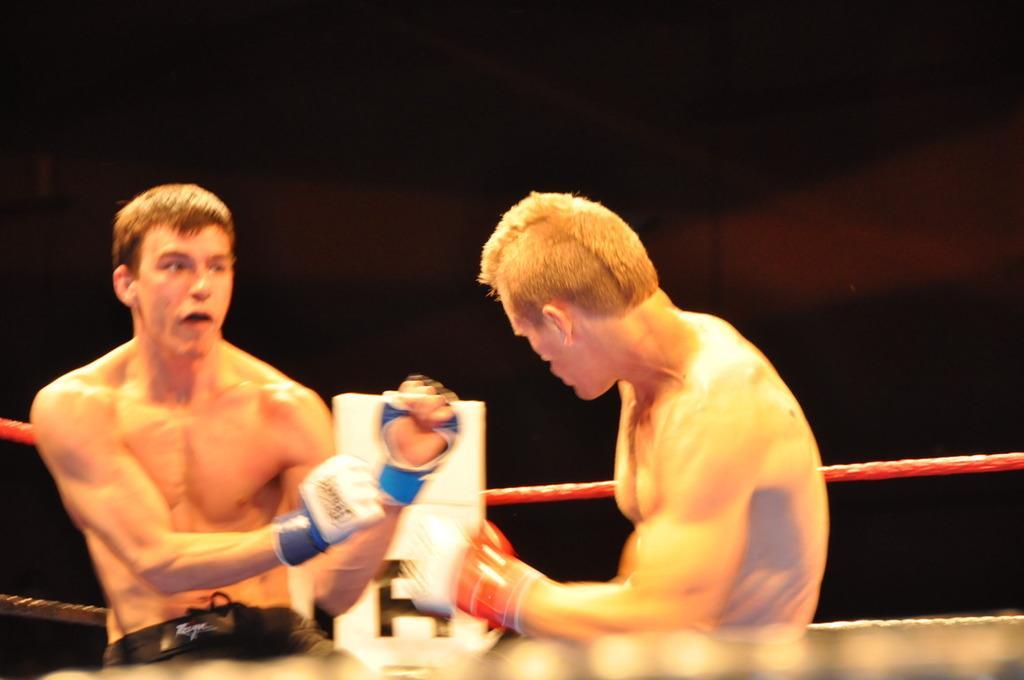Can you describe this image briefly? In this image, we can see two people. We can also see the boxing ring and a white colored object. We can see the dark background. 